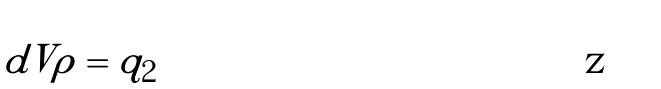Convert formula to latex. <formula><loc_0><loc_0><loc_500><loc_500>\int d V \rho = q _ { 2 }</formula> 